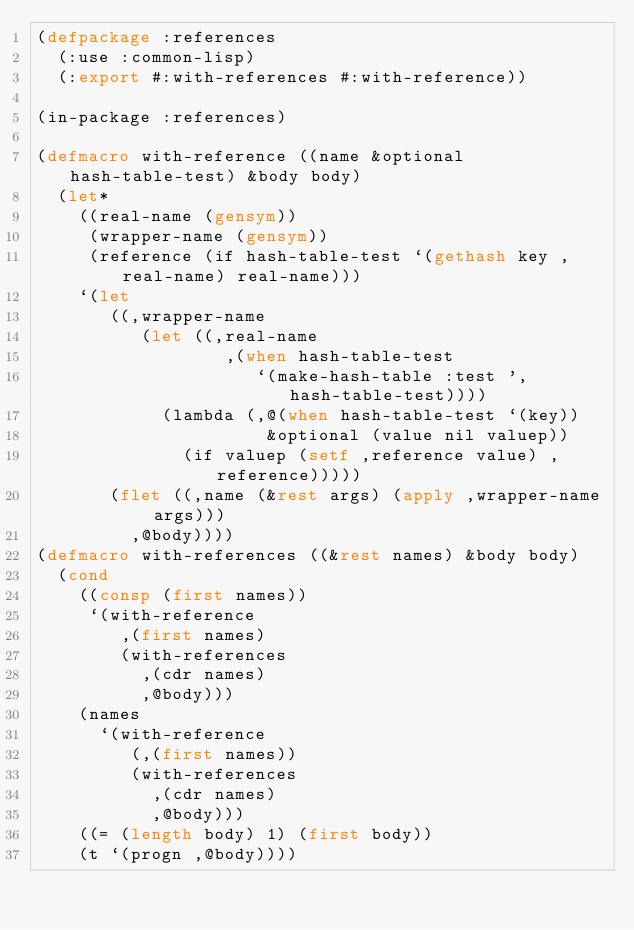Convert code to text. <code><loc_0><loc_0><loc_500><loc_500><_Lisp_>(defpackage :references
  (:use :common-lisp)
  (:export #:with-references #:with-reference))

(in-package :references)

(defmacro with-reference ((name &optional hash-table-test) &body body)
  (let*
    ((real-name (gensym))
     (wrapper-name (gensym))
     (reference (if hash-table-test `(gethash key ,real-name) real-name)))
    `(let
       ((,wrapper-name
          (let ((,real-name
                  ,(when hash-table-test
                     `(make-hash-table :test ',hash-table-test))))
            (lambda (,@(when hash-table-test `(key))
                      &optional (value nil valuep))
              (if valuep (setf ,reference value) ,reference)))))
       (flet ((,name (&rest args) (apply ,wrapper-name args)))
         ,@body))))
(defmacro with-references ((&rest names) &body body)
  (cond
    ((consp (first names))
     `(with-reference
        ,(first names)
        (with-references
          ,(cdr names)
          ,@body)))
    (names
      `(with-reference
         (,(first names))
         (with-references
           ,(cdr names)
           ,@body)))
    ((= (length body) 1) (first body))
    (t `(progn ,@body))))

</code> 